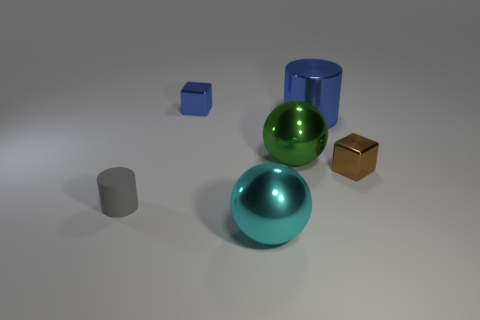Add 1 large green metallic spheres. How many objects exist? 7 Subtract all cyan spheres. How many spheres are left? 1 Subtract 1 cylinders. How many cylinders are left? 1 Subtract all big purple matte objects. Subtract all small brown metal things. How many objects are left? 5 Add 6 large green spheres. How many large green spheres are left? 7 Add 1 green things. How many green things exist? 2 Subtract 0 gray cubes. How many objects are left? 6 Subtract all red balls. Subtract all green blocks. How many balls are left? 2 